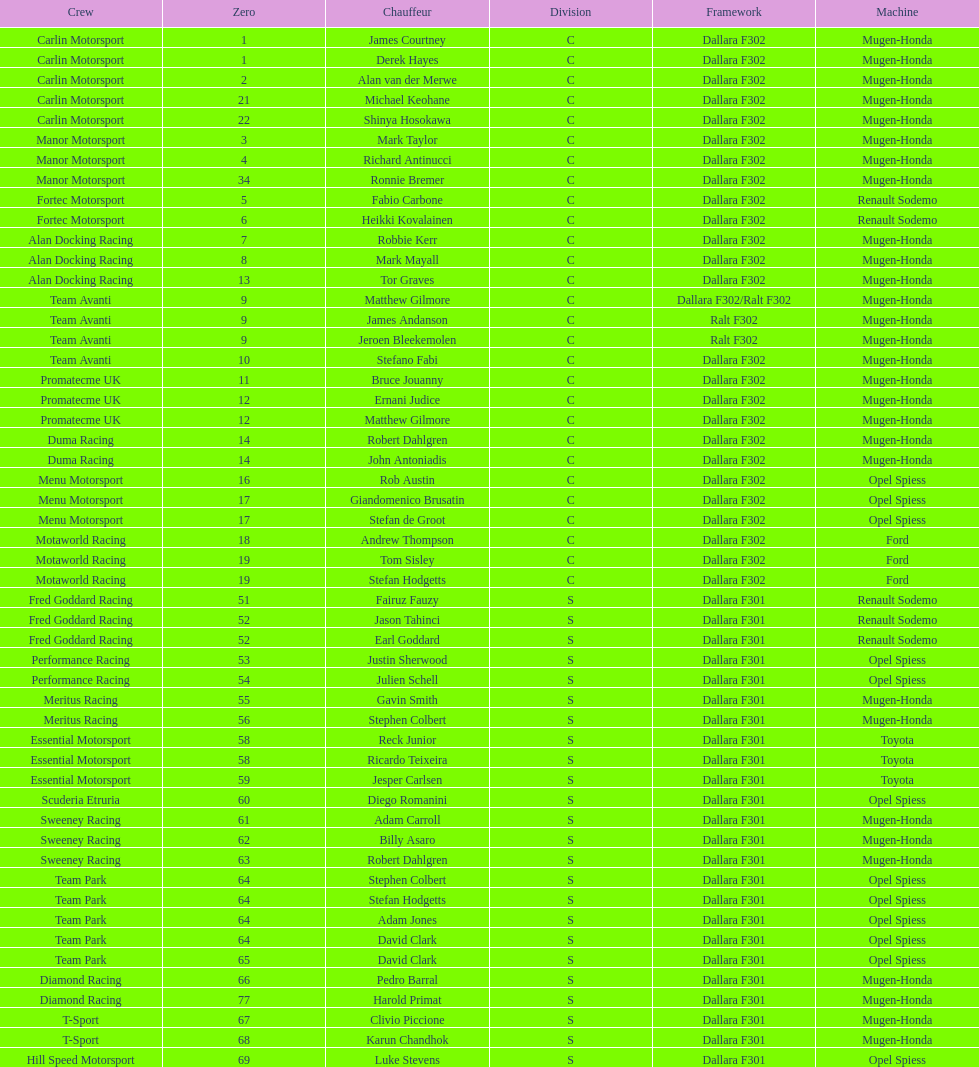What is the count of teams with drivers all originating from the same nation? 4. Write the full table. {'header': ['Crew', 'Zero', 'Chauffeur', 'Division', 'Framework', 'Machine'], 'rows': [['Carlin Motorsport', '1', 'James Courtney', 'C', 'Dallara F302', 'Mugen-Honda'], ['Carlin Motorsport', '1', 'Derek Hayes', 'C', 'Dallara F302', 'Mugen-Honda'], ['Carlin Motorsport', '2', 'Alan van der Merwe', 'C', 'Dallara F302', 'Mugen-Honda'], ['Carlin Motorsport', '21', 'Michael Keohane', 'C', 'Dallara F302', 'Mugen-Honda'], ['Carlin Motorsport', '22', 'Shinya Hosokawa', 'C', 'Dallara F302', 'Mugen-Honda'], ['Manor Motorsport', '3', 'Mark Taylor', 'C', 'Dallara F302', 'Mugen-Honda'], ['Manor Motorsport', '4', 'Richard Antinucci', 'C', 'Dallara F302', 'Mugen-Honda'], ['Manor Motorsport', '34', 'Ronnie Bremer', 'C', 'Dallara F302', 'Mugen-Honda'], ['Fortec Motorsport', '5', 'Fabio Carbone', 'C', 'Dallara F302', 'Renault Sodemo'], ['Fortec Motorsport', '6', 'Heikki Kovalainen', 'C', 'Dallara F302', 'Renault Sodemo'], ['Alan Docking Racing', '7', 'Robbie Kerr', 'C', 'Dallara F302', 'Mugen-Honda'], ['Alan Docking Racing', '8', 'Mark Mayall', 'C', 'Dallara F302', 'Mugen-Honda'], ['Alan Docking Racing', '13', 'Tor Graves', 'C', 'Dallara F302', 'Mugen-Honda'], ['Team Avanti', '9', 'Matthew Gilmore', 'C', 'Dallara F302/Ralt F302', 'Mugen-Honda'], ['Team Avanti', '9', 'James Andanson', 'C', 'Ralt F302', 'Mugen-Honda'], ['Team Avanti', '9', 'Jeroen Bleekemolen', 'C', 'Ralt F302', 'Mugen-Honda'], ['Team Avanti', '10', 'Stefano Fabi', 'C', 'Dallara F302', 'Mugen-Honda'], ['Promatecme UK', '11', 'Bruce Jouanny', 'C', 'Dallara F302', 'Mugen-Honda'], ['Promatecme UK', '12', 'Ernani Judice', 'C', 'Dallara F302', 'Mugen-Honda'], ['Promatecme UK', '12', 'Matthew Gilmore', 'C', 'Dallara F302', 'Mugen-Honda'], ['Duma Racing', '14', 'Robert Dahlgren', 'C', 'Dallara F302', 'Mugen-Honda'], ['Duma Racing', '14', 'John Antoniadis', 'C', 'Dallara F302', 'Mugen-Honda'], ['Menu Motorsport', '16', 'Rob Austin', 'C', 'Dallara F302', 'Opel Spiess'], ['Menu Motorsport', '17', 'Giandomenico Brusatin', 'C', 'Dallara F302', 'Opel Spiess'], ['Menu Motorsport', '17', 'Stefan de Groot', 'C', 'Dallara F302', 'Opel Spiess'], ['Motaworld Racing', '18', 'Andrew Thompson', 'C', 'Dallara F302', 'Ford'], ['Motaworld Racing', '19', 'Tom Sisley', 'C', 'Dallara F302', 'Ford'], ['Motaworld Racing', '19', 'Stefan Hodgetts', 'C', 'Dallara F302', 'Ford'], ['Fred Goddard Racing', '51', 'Fairuz Fauzy', 'S', 'Dallara F301', 'Renault Sodemo'], ['Fred Goddard Racing', '52', 'Jason Tahinci', 'S', 'Dallara F301', 'Renault Sodemo'], ['Fred Goddard Racing', '52', 'Earl Goddard', 'S', 'Dallara F301', 'Renault Sodemo'], ['Performance Racing', '53', 'Justin Sherwood', 'S', 'Dallara F301', 'Opel Spiess'], ['Performance Racing', '54', 'Julien Schell', 'S', 'Dallara F301', 'Opel Spiess'], ['Meritus Racing', '55', 'Gavin Smith', 'S', 'Dallara F301', 'Mugen-Honda'], ['Meritus Racing', '56', 'Stephen Colbert', 'S', 'Dallara F301', 'Mugen-Honda'], ['Essential Motorsport', '58', 'Reck Junior', 'S', 'Dallara F301', 'Toyota'], ['Essential Motorsport', '58', 'Ricardo Teixeira', 'S', 'Dallara F301', 'Toyota'], ['Essential Motorsport', '59', 'Jesper Carlsen', 'S', 'Dallara F301', 'Toyota'], ['Scuderia Etruria', '60', 'Diego Romanini', 'S', 'Dallara F301', 'Opel Spiess'], ['Sweeney Racing', '61', 'Adam Carroll', 'S', 'Dallara F301', 'Mugen-Honda'], ['Sweeney Racing', '62', 'Billy Asaro', 'S', 'Dallara F301', 'Mugen-Honda'], ['Sweeney Racing', '63', 'Robert Dahlgren', 'S', 'Dallara F301', 'Mugen-Honda'], ['Team Park', '64', 'Stephen Colbert', 'S', 'Dallara F301', 'Opel Spiess'], ['Team Park', '64', 'Stefan Hodgetts', 'S', 'Dallara F301', 'Opel Spiess'], ['Team Park', '64', 'Adam Jones', 'S', 'Dallara F301', 'Opel Spiess'], ['Team Park', '64', 'David Clark', 'S', 'Dallara F301', 'Opel Spiess'], ['Team Park', '65', 'David Clark', 'S', 'Dallara F301', 'Opel Spiess'], ['Diamond Racing', '66', 'Pedro Barral', 'S', 'Dallara F301', 'Mugen-Honda'], ['Diamond Racing', '77', 'Harold Primat', 'S', 'Dallara F301', 'Mugen-Honda'], ['T-Sport', '67', 'Clivio Piccione', 'S', 'Dallara F301', 'Mugen-Honda'], ['T-Sport', '68', 'Karun Chandhok', 'S', 'Dallara F301', 'Mugen-Honda'], ['Hill Speed Motorsport', '69', 'Luke Stevens', 'S', 'Dallara F301', 'Opel Spiess']]} 